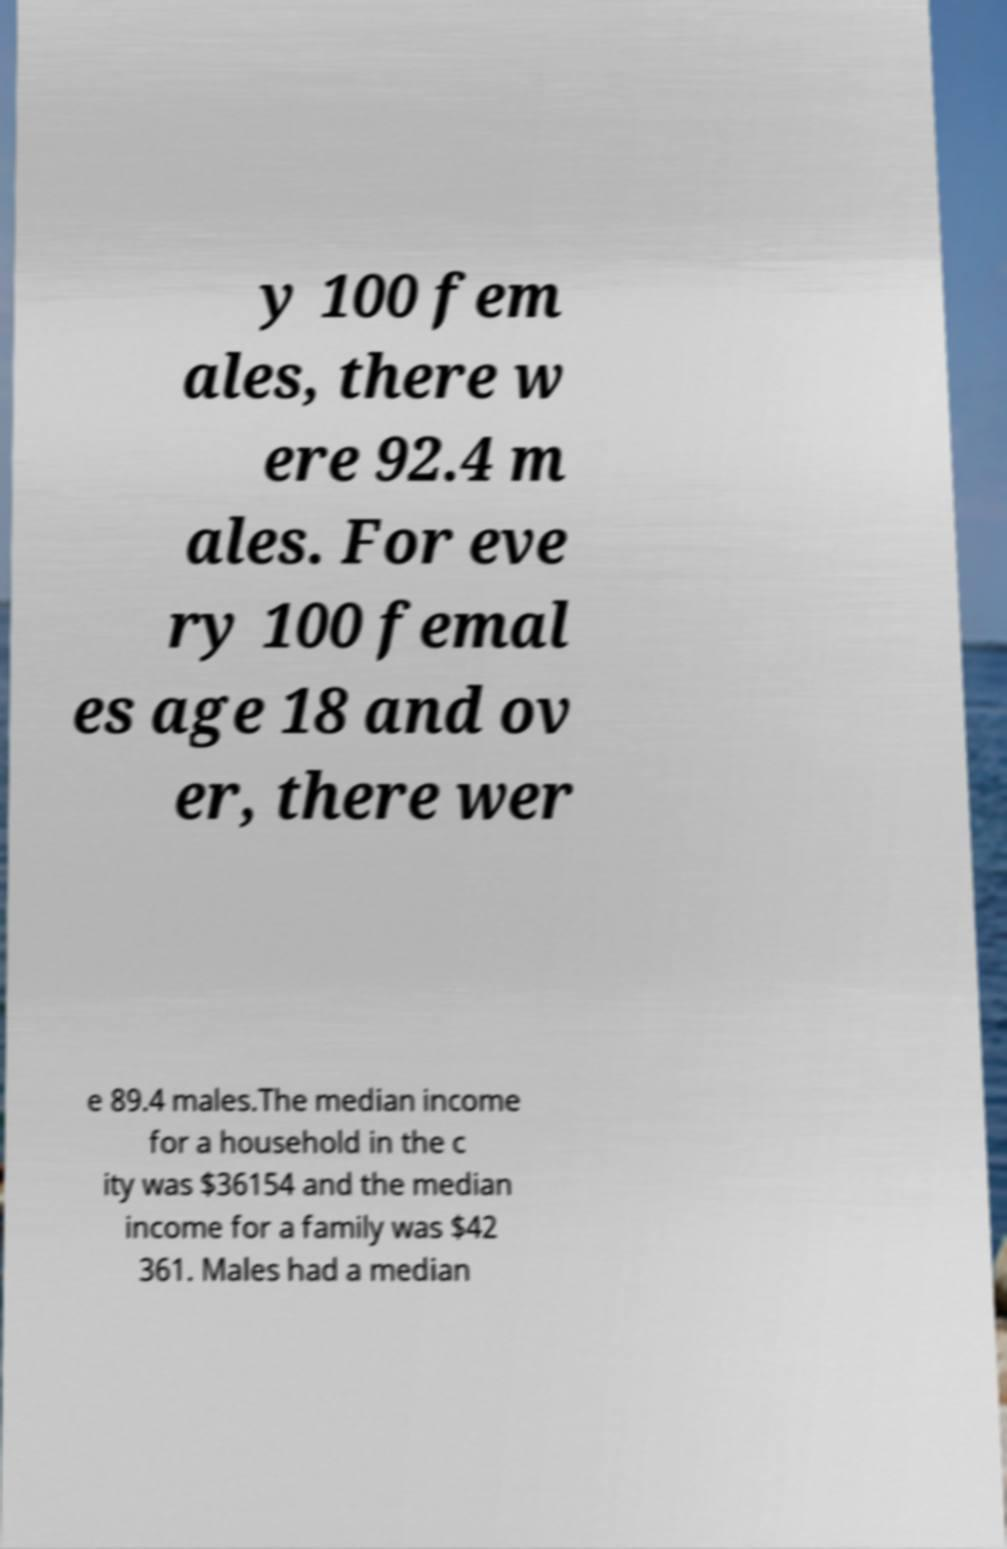Can you read and provide the text displayed in the image?This photo seems to have some interesting text. Can you extract and type it out for me? y 100 fem ales, there w ere 92.4 m ales. For eve ry 100 femal es age 18 and ov er, there wer e 89.4 males.The median income for a household in the c ity was $36154 and the median income for a family was $42 361. Males had a median 